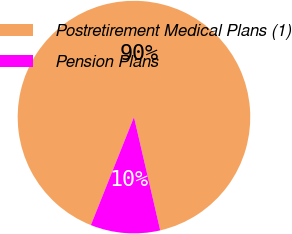Convert chart to OTSL. <chart><loc_0><loc_0><loc_500><loc_500><pie_chart><fcel>Postretirement Medical Plans (1)<fcel>Pension Plans<nl><fcel>90.33%<fcel>9.67%<nl></chart> 